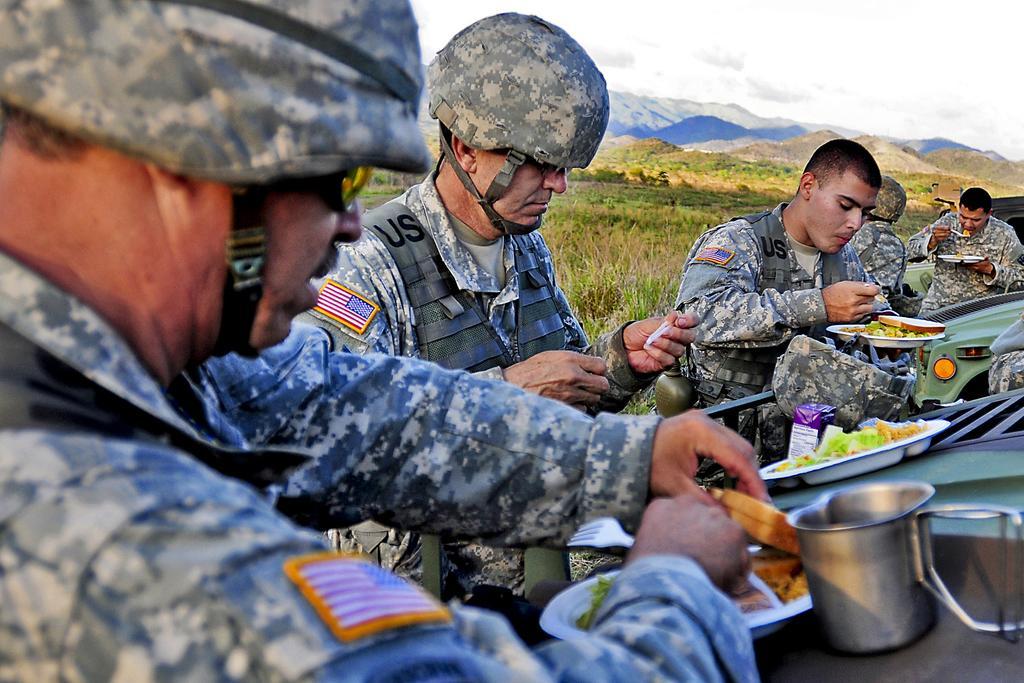How would you summarize this image in a sentence or two? This is an outside view. Here I can see few men wearing uniforms, sitting facing towards the right side and eating. In front of these people there are few bowls and some other objects. In the background, I can see the grass, trees and mountains. At the top of the image I can see the sky. 